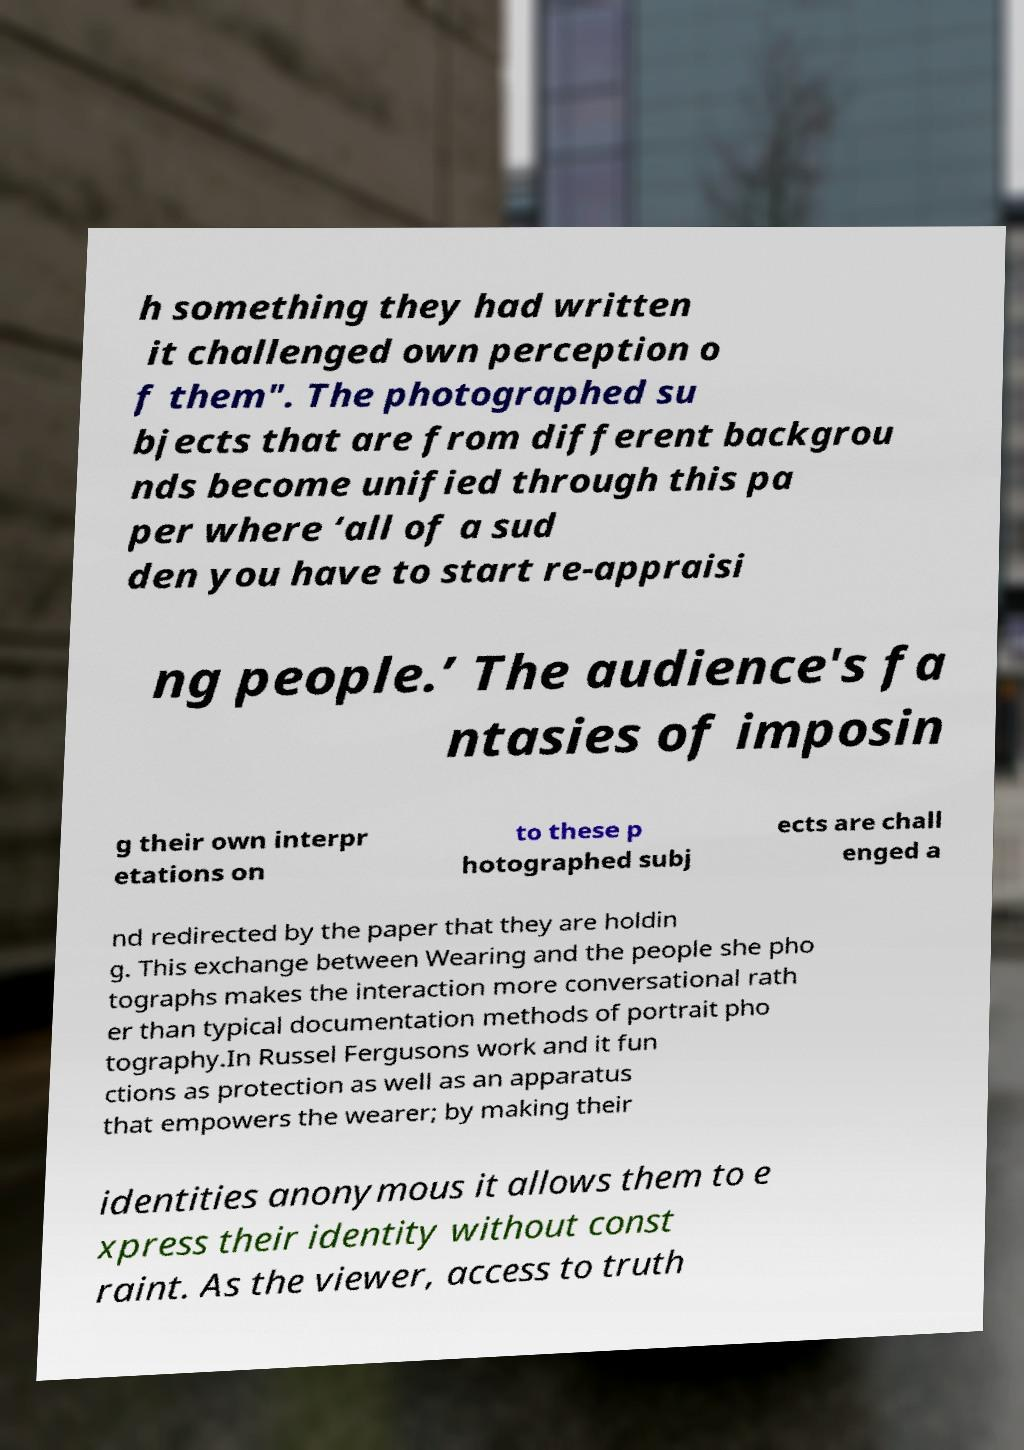There's text embedded in this image that I need extracted. Can you transcribe it verbatim? h something they had written it challenged own perception o f them". The photographed su bjects that are from different backgrou nds become unified through this pa per where ‘all of a sud den you have to start re-appraisi ng people.’ The audience's fa ntasies of imposin g their own interpr etations on to these p hotographed subj ects are chall enged a nd redirected by the paper that they are holdin g. This exchange between Wearing and the people she pho tographs makes the interaction more conversational rath er than typical documentation methods of portrait pho tography.In Russel Fergusons work and it fun ctions as protection as well as an apparatus that empowers the wearer; by making their identities anonymous it allows them to e xpress their identity without const raint. As the viewer, access to truth 